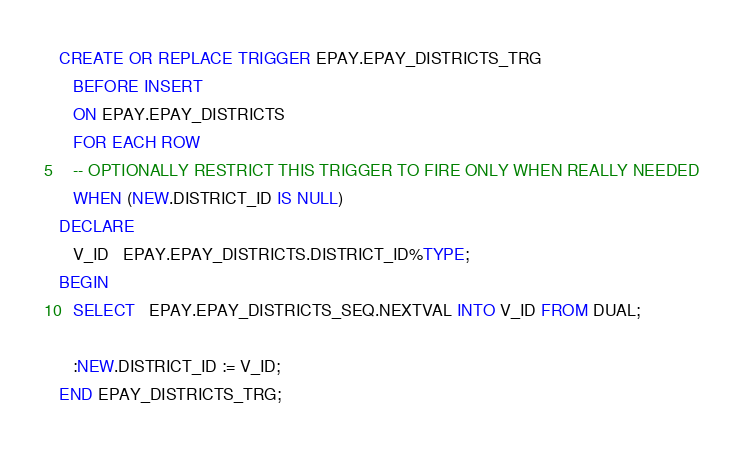<code> <loc_0><loc_0><loc_500><loc_500><_SQL_>
CREATE OR REPLACE TRIGGER EPAY.EPAY_DISTRICTS_TRG
   BEFORE INSERT
   ON EPAY.EPAY_DISTRICTS
   FOR EACH ROW
   -- OPTIONALLY RESTRICT THIS TRIGGER TO FIRE ONLY WHEN REALLY NEEDED
   WHEN (NEW.DISTRICT_ID IS NULL)
DECLARE
   V_ID   EPAY.EPAY_DISTRICTS.DISTRICT_ID%TYPE;
BEGIN
   SELECT   EPAY.EPAY_DISTRICTS_SEQ.NEXTVAL INTO V_ID FROM DUAL;

   :NEW.DISTRICT_ID := V_ID;
END EPAY_DISTRICTS_TRG;</code> 